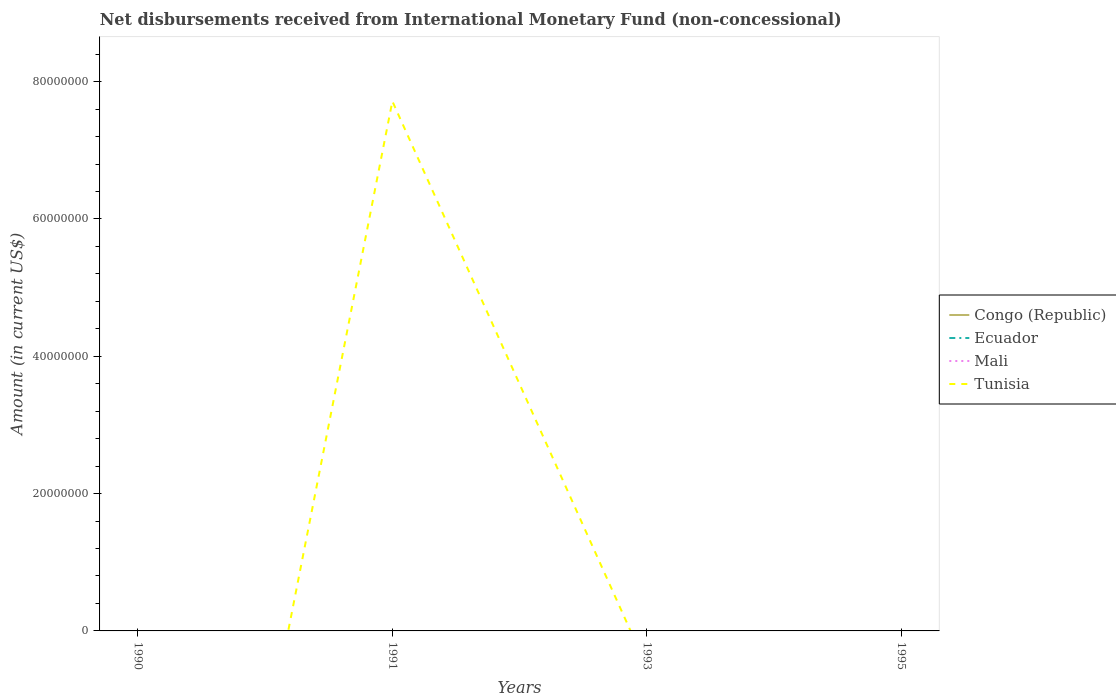Does the line corresponding to Mali intersect with the line corresponding to Congo (Republic)?
Your answer should be very brief. Yes. Is the number of lines equal to the number of legend labels?
Make the answer very short. No. What is the difference between the highest and the second highest amount of disbursements received from International Monetary Fund in Tunisia?
Provide a short and direct response. 7.71e+07. What is the difference between the highest and the lowest amount of disbursements received from International Monetary Fund in Tunisia?
Offer a very short reply. 1. How many years are there in the graph?
Ensure brevity in your answer.  4. What is the difference between two consecutive major ticks on the Y-axis?
Provide a short and direct response. 2.00e+07. Are the values on the major ticks of Y-axis written in scientific E-notation?
Give a very brief answer. No. How are the legend labels stacked?
Give a very brief answer. Vertical. What is the title of the graph?
Give a very brief answer. Net disbursements received from International Monetary Fund (non-concessional). What is the label or title of the X-axis?
Ensure brevity in your answer.  Years. What is the Amount (in current US$) in Congo (Republic) in 1990?
Ensure brevity in your answer.  0. What is the Amount (in current US$) of Ecuador in 1990?
Keep it short and to the point. 0. What is the Amount (in current US$) in Mali in 1990?
Keep it short and to the point. 0. What is the Amount (in current US$) in Ecuador in 1991?
Your answer should be compact. 0. What is the Amount (in current US$) in Tunisia in 1991?
Keep it short and to the point. 7.71e+07. What is the Amount (in current US$) of Ecuador in 1993?
Make the answer very short. 0. What is the Amount (in current US$) of Mali in 1993?
Provide a succinct answer. 0. What is the Amount (in current US$) in Congo (Republic) in 1995?
Offer a very short reply. 0. Across all years, what is the maximum Amount (in current US$) in Tunisia?
Offer a very short reply. 7.71e+07. What is the total Amount (in current US$) of Congo (Republic) in the graph?
Provide a short and direct response. 0. What is the total Amount (in current US$) of Tunisia in the graph?
Your answer should be very brief. 7.71e+07. What is the average Amount (in current US$) of Ecuador per year?
Keep it short and to the point. 0. What is the average Amount (in current US$) in Mali per year?
Keep it short and to the point. 0. What is the average Amount (in current US$) in Tunisia per year?
Your response must be concise. 1.93e+07. What is the difference between the highest and the lowest Amount (in current US$) in Tunisia?
Your answer should be very brief. 7.71e+07. 